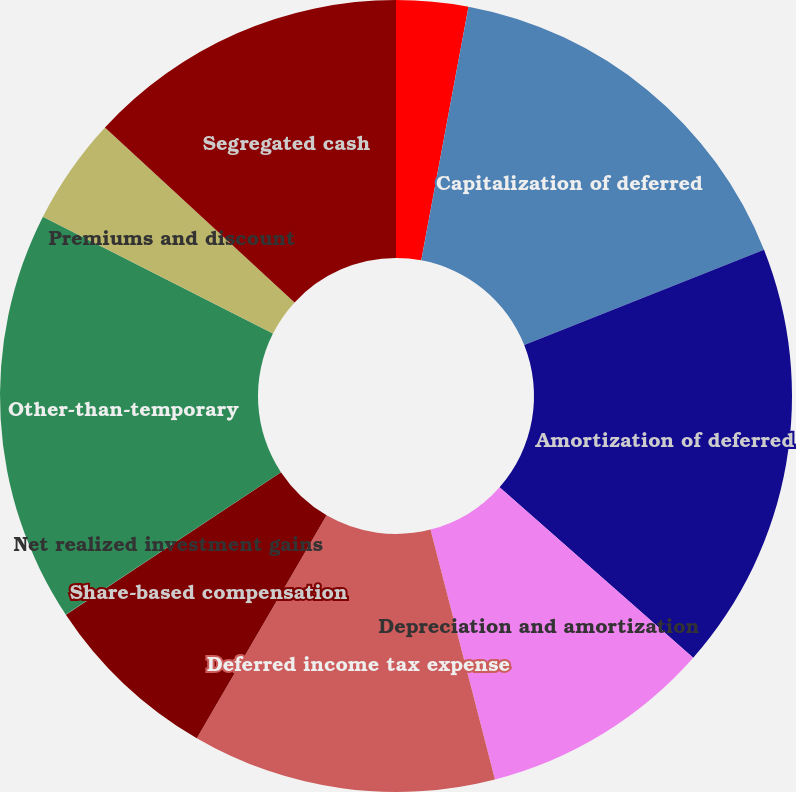Convert chart to OTSL. <chart><loc_0><loc_0><loc_500><loc_500><pie_chart><fcel>Net income (loss)<fcel>Capitalization of deferred<fcel>Amortization of deferred<fcel>Depreciation and amortization<fcel>Deferred income tax expense<fcel>Share-based compensation<fcel>Net realized investment gains<fcel>Other-than-temporary<fcel>Premiums and discount<fcel>Segregated cash<nl><fcel>2.93%<fcel>16.05%<fcel>17.51%<fcel>9.49%<fcel>12.41%<fcel>7.3%<fcel>0.01%<fcel>16.78%<fcel>4.38%<fcel>13.14%<nl></chart> 